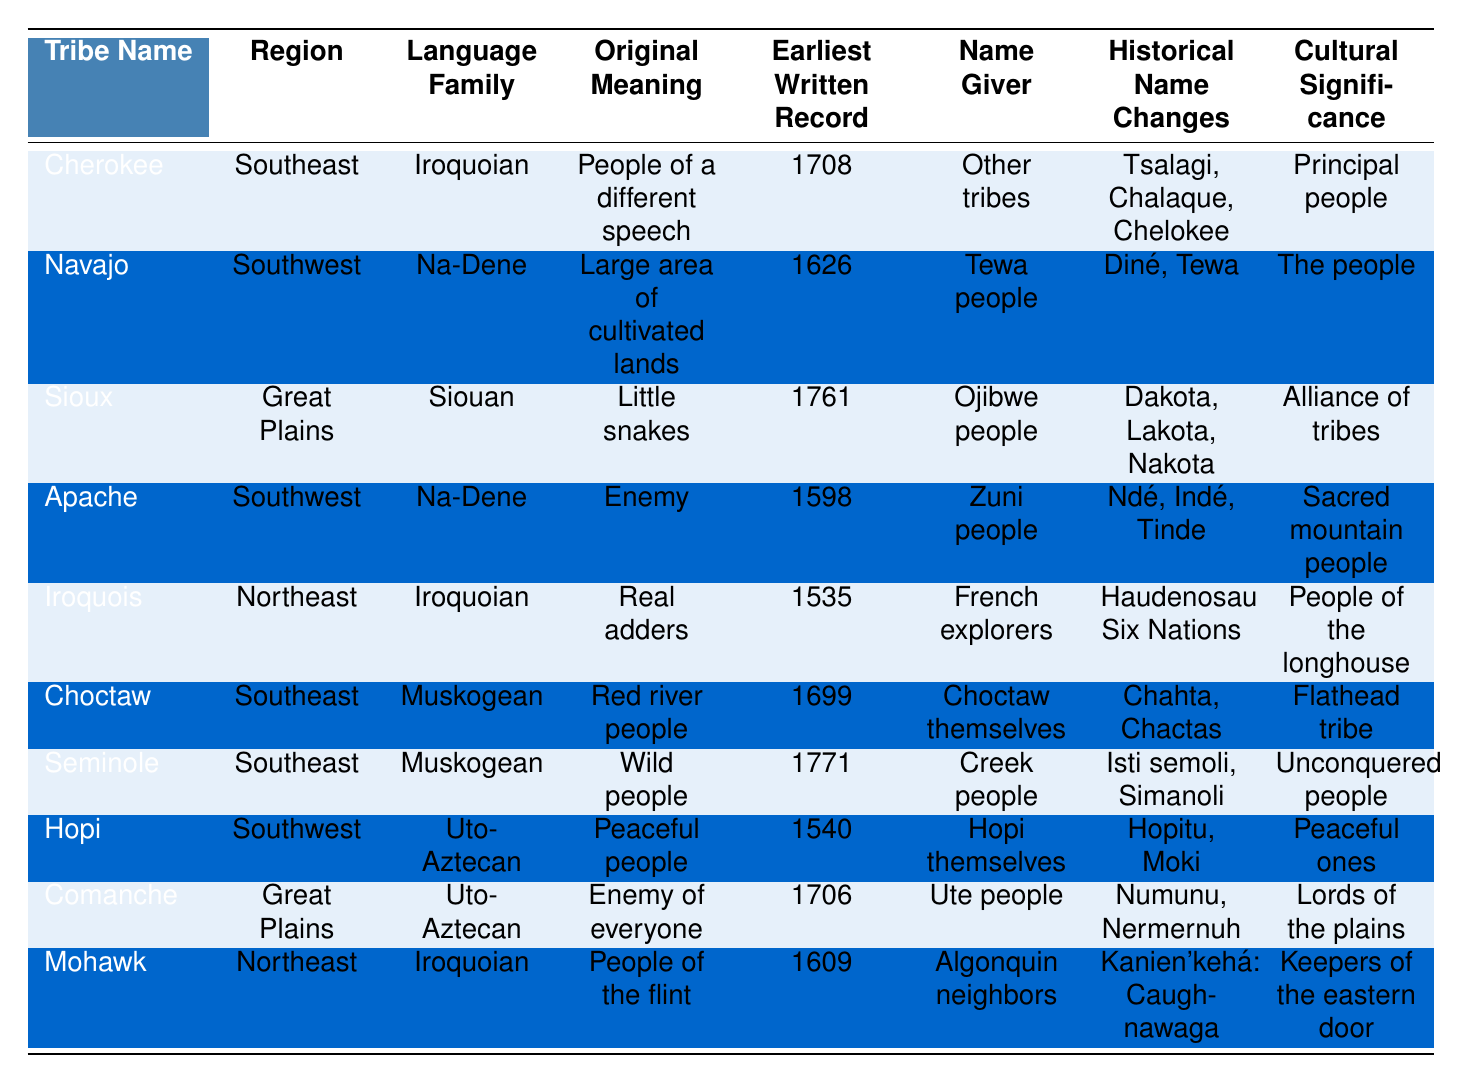What region are the Iroquois from? The Iroquois are listed in the table under the "Region" column, which shows they are from the Northeast.
Answer: Northeast Which tribe has the earliest written record? The earliest written record in the table is for the Iroquois, with a date of 1535.
Answer: Iroquois What is the original meaning of the name "Comanche"? According to the table, the original meaning of "Comanche" is "Enemy of everyone."
Answer: Enemy of everyone How many tribes in the table belong to the Uto-Aztecan language family? The table lists two tribes under the Uto-Aztecan language family: Hopi and Comanche. Therefore, the count is 2.
Answer: 2 Is the original meaning of "Apache" an enemy? The table indicates that the original meaning of "Apache" is "Enemy," confirming this fact.
Answer: Yes Which language family is represented by the most tribes? Upon reviewing the "Language Family" column, Iroquoian appears three times for the tribes Cherokee, Iroquois, and Mohawk, the most of any family.
Answer: Iroquoian What is the cultural significance of the Seminole tribe? The table shows that the cultural significance of the Seminole tribe is described as "Unconquered people."
Answer: Unconquered people How do the historical name changes of Sioux compare to those of Navajo? The table lists multiple historical names for Sioux (Dakota, Lakota, Nakota) compared to only two for Navajo (Diné, Tewa), showing Sioux has more name variations.
Answer: Sioux has more variations What is the difference in the earliest written records between the Choctaw and the Mohawk? Choctaw's earliest record is 1699, and Mohawk's is 1609, which means the difference is 90 years (1699 - 1609).
Answer: 90 years Which name giver was responsible for naming the Iroquois? The name giver responsible for the Iroquois is listed as "French explorers" in the table.
Answer: French explorers 